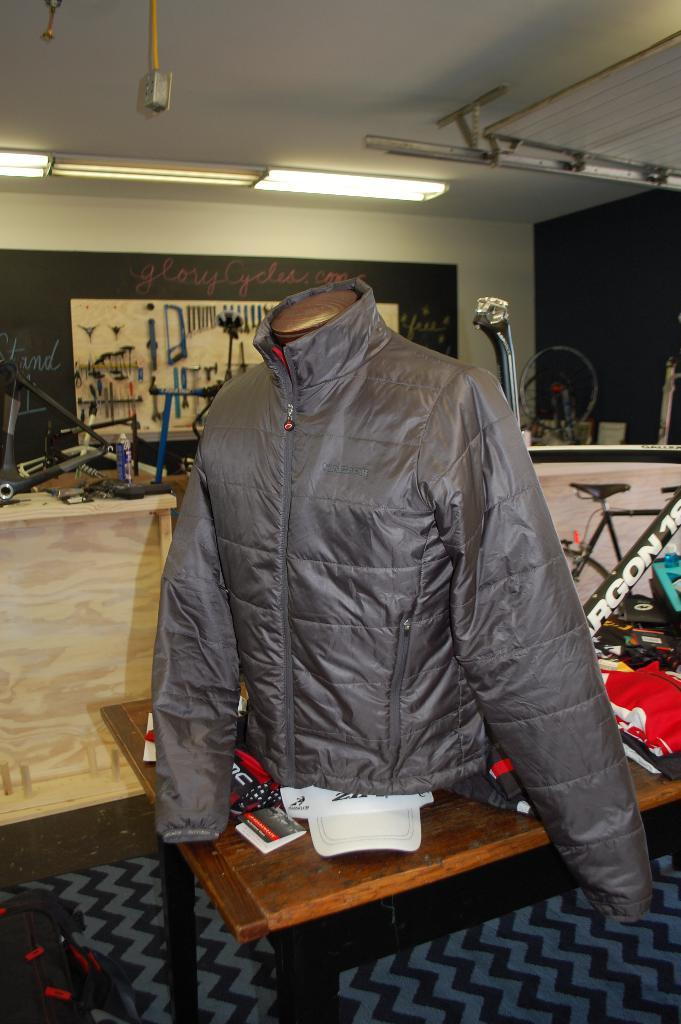What is placed on the table in the image? There is a coat on a table in the image. What can be seen in the background of the image? There is a bicycle, spare parts of a bicycle, a wall, and lights in the background. What type of muscle is being exercised by the coat in the image? There is no muscle or exercise depicted in the image; it features a coat on a table and various background elements. 